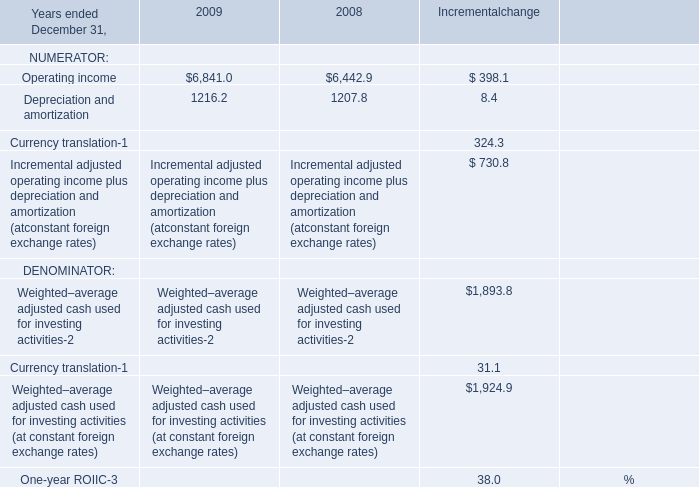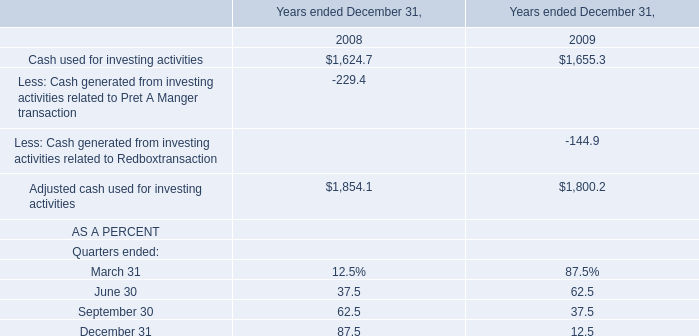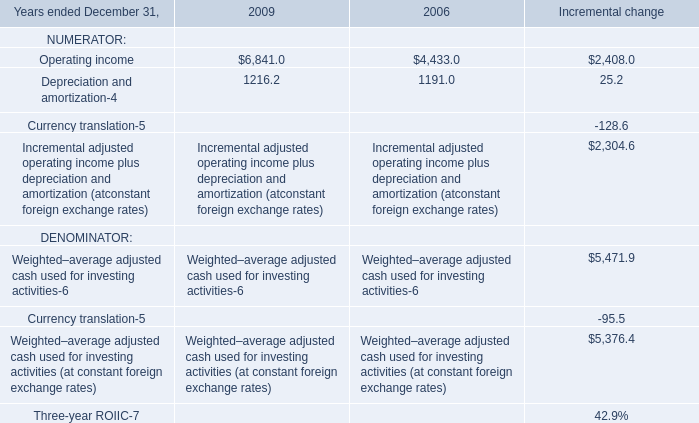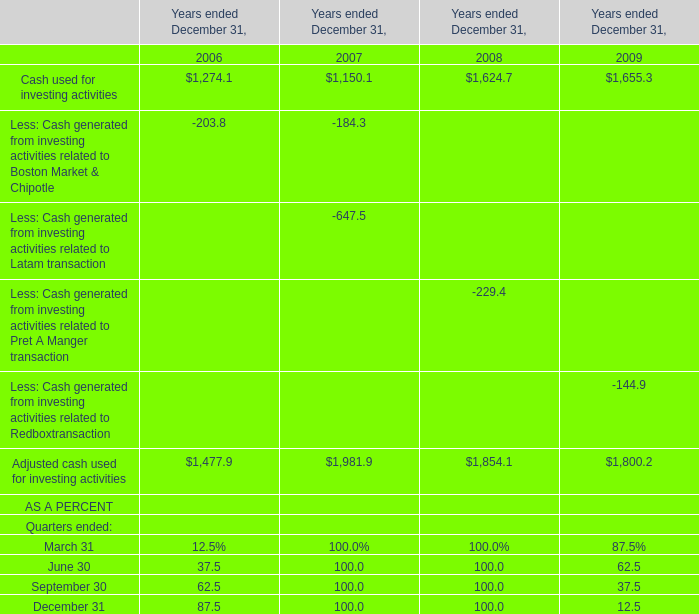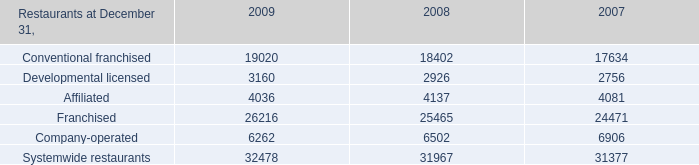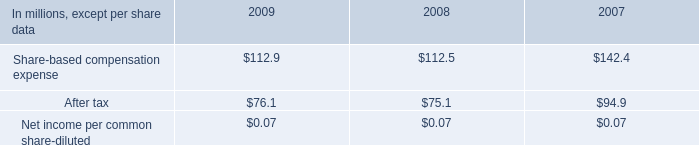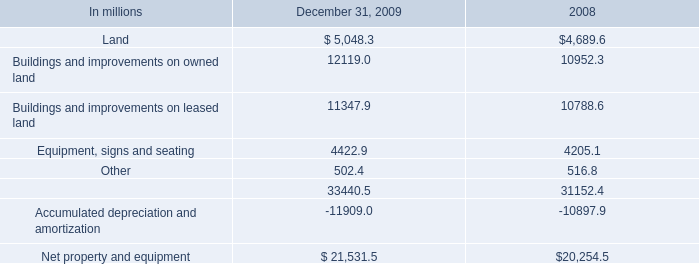In the year with largest amount of Depreciation and amortization, what's the sum of NUMERATOR? 
Computations: (4433.0 + 1191.0)
Answer: 5624.0. 